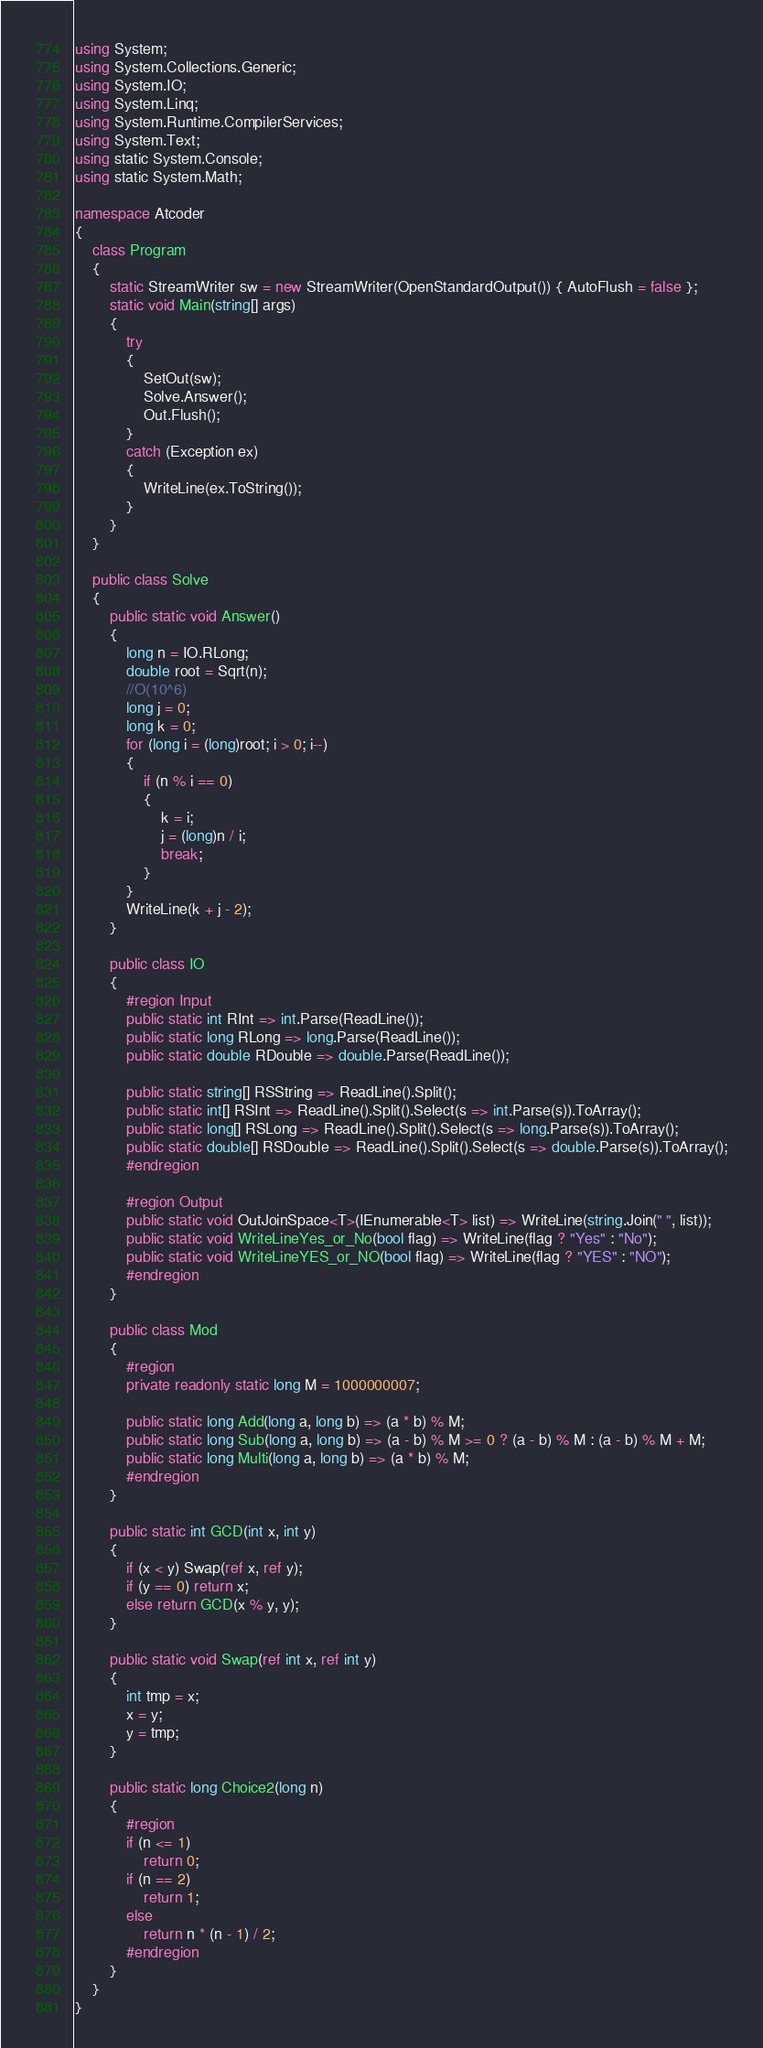Convert code to text. <code><loc_0><loc_0><loc_500><loc_500><_C#_>using System;
using System.Collections.Generic;
using System.IO;
using System.Linq;
using System.Runtime.CompilerServices;
using System.Text;
using static System.Console;
using static System.Math;

namespace Atcoder
{
    class Program
    {
        static StreamWriter sw = new StreamWriter(OpenStandardOutput()) { AutoFlush = false };
        static void Main(string[] args)
        {
            try
            {
                SetOut(sw);
                Solve.Answer();
                Out.Flush();
            }
            catch (Exception ex)
            {
                WriteLine(ex.ToString());
            }
        }
    }

    public class Solve
    {
        public static void Answer()
        {
            long n = IO.RLong;
            double root = Sqrt(n);
            //O(10^6)
            long j = 0;
            long k = 0;
            for (long i = (long)root; i > 0; i--)
            {
                if (n % i == 0)
                {
                    k = i;
                    j = (long)n / i;
                    break;
                }
            }
            WriteLine(k + j - 2);
        }

        public class IO
        {
            #region Input
            public static int RInt => int.Parse(ReadLine());
            public static long RLong => long.Parse(ReadLine());
            public static double RDouble => double.Parse(ReadLine());

            public static string[] RSString => ReadLine().Split();
            public static int[] RSInt => ReadLine().Split().Select(s => int.Parse(s)).ToArray();
            public static long[] RSLong => ReadLine().Split().Select(s => long.Parse(s)).ToArray();
            public static double[] RSDouble => ReadLine().Split().Select(s => double.Parse(s)).ToArray();
            #endregion

            #region Output
            public static void OutJoinSpace<T>(IEnumerable<T> list) => WriteLine(string.Join(" ", list));
            public static void WriteLineYes_or_No(bool flag) => WriteLine(flag ? "Yes" : "No");
            public static void WriteLineYES_or_NO(bool flag) => WriteLine(flag ? "YES" : "NO");
            #endregion
        }

        public class Mod
        {
            #region
            private readonly static long M = 1000000007;

            public static long Add(long a, long b) => (a * b) % M;
            public static long Sub(long a, long b) => (a - b) % M >= 0 ? (a - b) % M : (a - b) % M + M;
            public static long Multi(long a, long b) => (a * b) % M;
            #endregion
        }

        public static int GCD(int x, int y)
        {
            if (x < y) Swap(ref x, ref y);
            if (y == 0) return x;
            else return GCD(x % y, y);
        }

        public static void Swap(ref int x, ref int y)
        {
            int tmp = x;
            x = y;
            y = tmp;
        }

        public static long Choice2(long n)
        {
            #region
            if (n <= 1)
                return 0;
            if (n == 2)
                return 1;
            else
                return n * (n - 1) / 2;
            #endregion
        }
    }
}</code> 